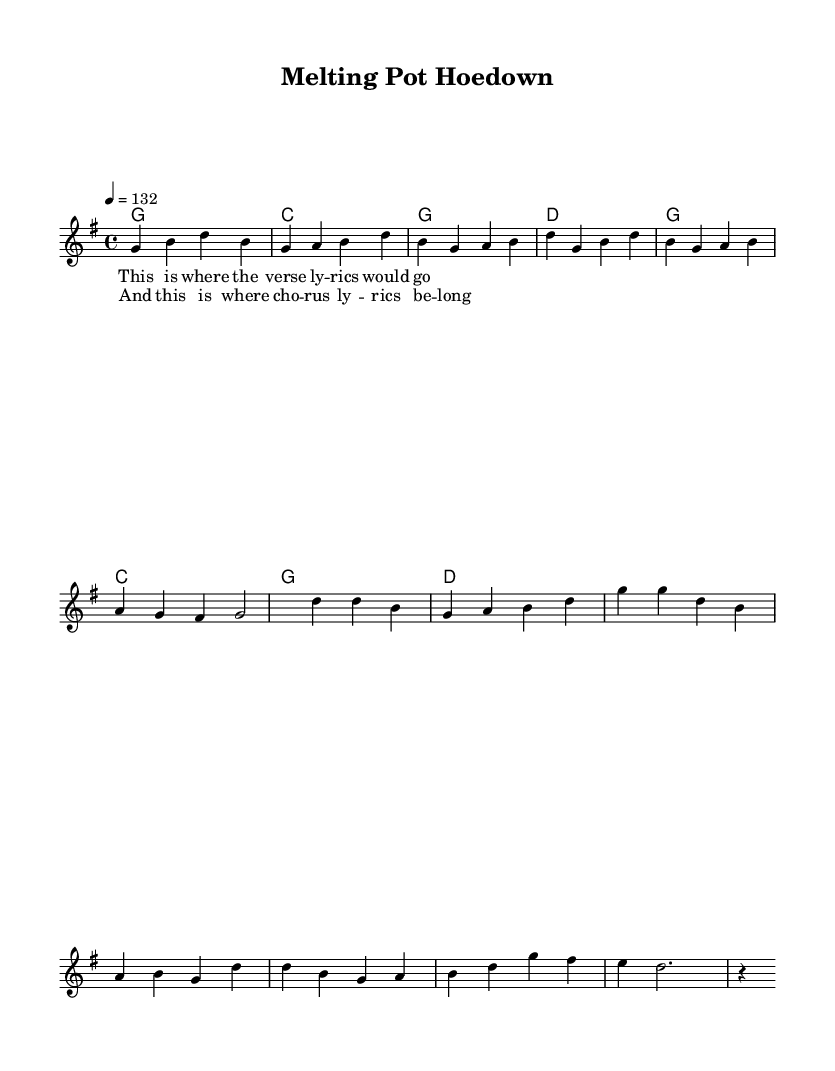What is the key signature of this music? The key signature indicated at the beginning of the score is G major, which has one sharp (F#).
Answer: G major What is the time signature of this piece? The time signature is shown at the beginning of the score as 4/4, meaning there are four beats in each measure and the quarter note gets one beat.
Answer: 4/4 What is the tempo marking for this piece? The tempo is marked as equals to 132 beats per minute, indicating a lively and upbeat pace.
Answer: 132 How many measures are in the verse? There are a total of 6 measures indicated in the melody section for the verse before it transitions to the chorus.
Answer: 6 What chords are used in the chorus? The chords used in the chorus consist of G, C, and D, which are typical of country rock music, providing a harmonious and supportive structure.
Answer: G, C, D What is the primary theme of this country rock anthem? The anthem celebrates cultural diversity, which is reflected in its upbeat melody and lyrics that emphasize unity and inclusion.
Answer: Cultural diversity What type of lyrics are typically associated with this genre? The lyrics often include themes of celebration, community, and personal experiences that resonate with a diverse audience, framing the song's upbeat character.
Answer: Celebration and community 